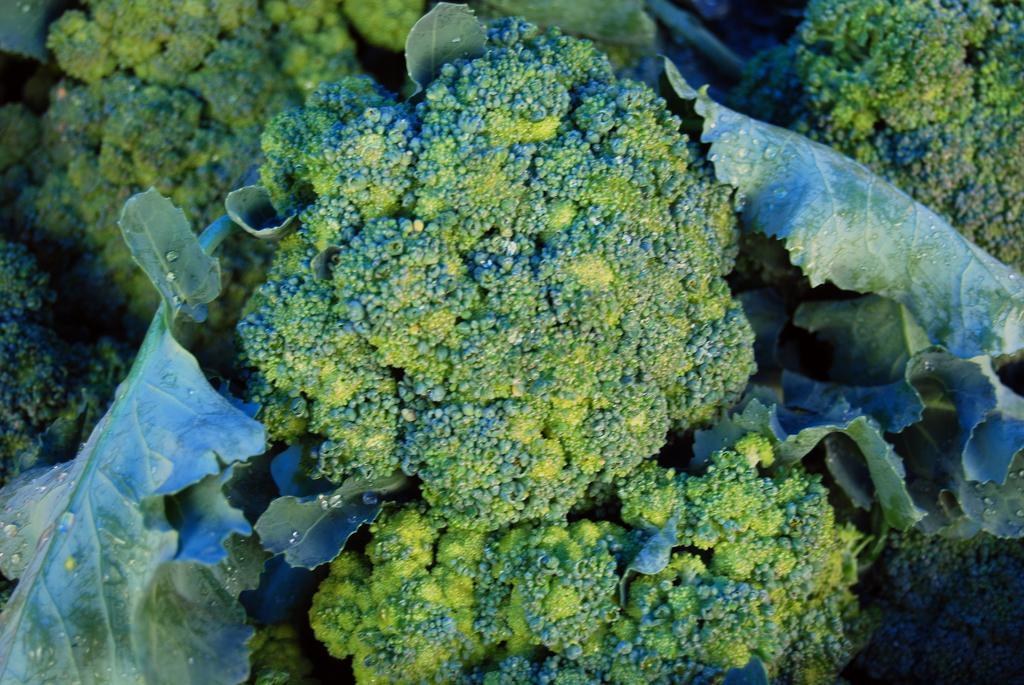In one or two sentences, can you explain what this image depicts? In this image I can see few broccoli along with the leaves. On the leaves I can see the water drops. 